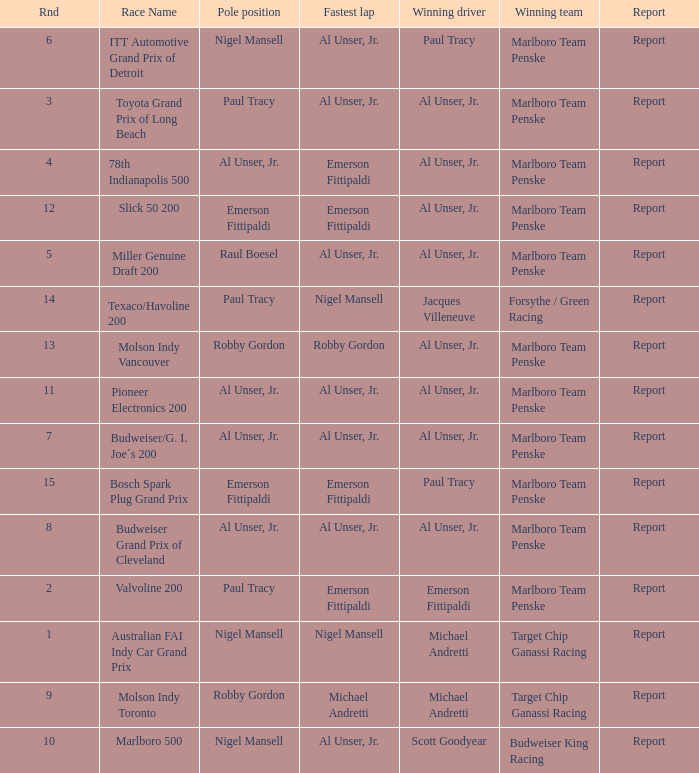What's the report of the race won by Michael Andretti, with Nigel Mansell driving the fastest lap? Report. 